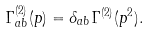<formula> <loc_0><loc_0><loc_500><loc_500>\Gamma ^ { ( 2 ) } _ { a b } ( p ) = \delta _ { a b } \Gamma ^ { ( 2 ) } ( p ^ { 2 } ) .</formula> 